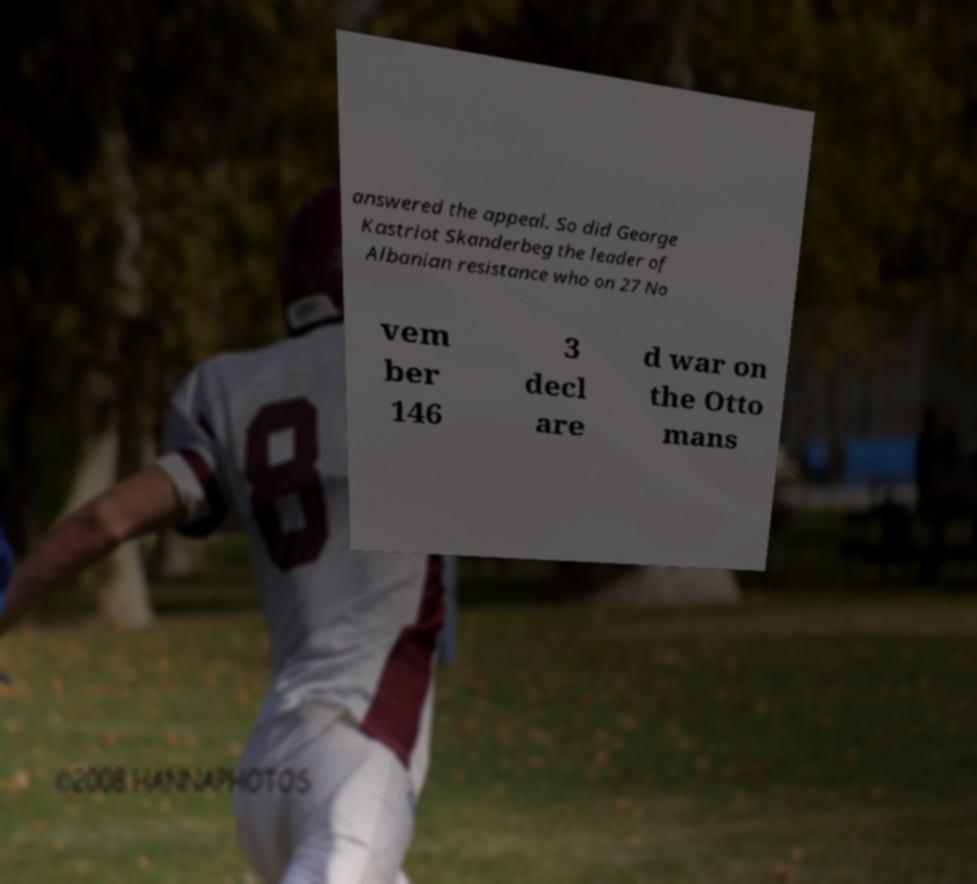Please identify and transcribe the text found in this image. answered the appeal. So did George Kastriot Skanderbeg the leader of Albanian resistance who on 27 No vem ber 146 3 decl are d war on the Otto mans 